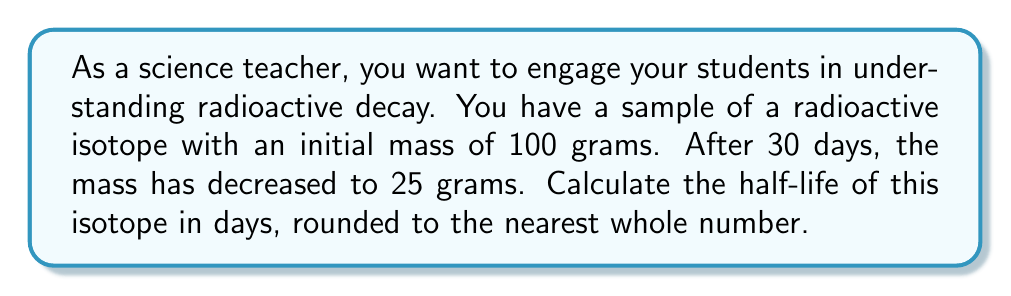Could you help me with this problem? Let's approach this step-by-step using the exponential decay formula:

1) The general form of the exponential decay formula is:

   $$ N(t) = N_0 \cdot e^{-\lambda t} $$

   Where:
   $N(t)$ is the amount at time $t$
   $N_0$ is the initial amount
   $\lambda$ is the decay constant
   $t$ is the time elapsed

2) We know:
   $N_0 = 100$ grams
   $N(t) = 25$ grams
   $t = 30$ days

3) Substituting these values:

   $$ 25 = 100 \cdot e^{-\lambda \cdot 30} $$

4) Dividing both sides by 100:

   $$ 0.25 = e^{-30\lambda} $$

5) Taking the natural log of both sides:

   $$ \ln(0.25) = -30\lambda $$

6) Solving for $\lambda$:

   $$ \lambda = -\frac{\ln(0.25)}{30} \approx 0.0462 $$

7) The half-life $t_{1/2}$ is related to $\lambda$ by:

   $$ t_{1/2} = \frac{\ln(2)}{\lambda} $$

8) Substituting our value for $\lambda$:

   $$ t_{1/2} = \frac{\ln(2)}{0.0462} \approx 15.01 \text{ days} $$

9) Rounding to the nearest whole number:

   $$ t_{1/2} \approx 15 \text{ days} $$
Answer: The half-life of the radioactive isotope is approximately 15 days. 